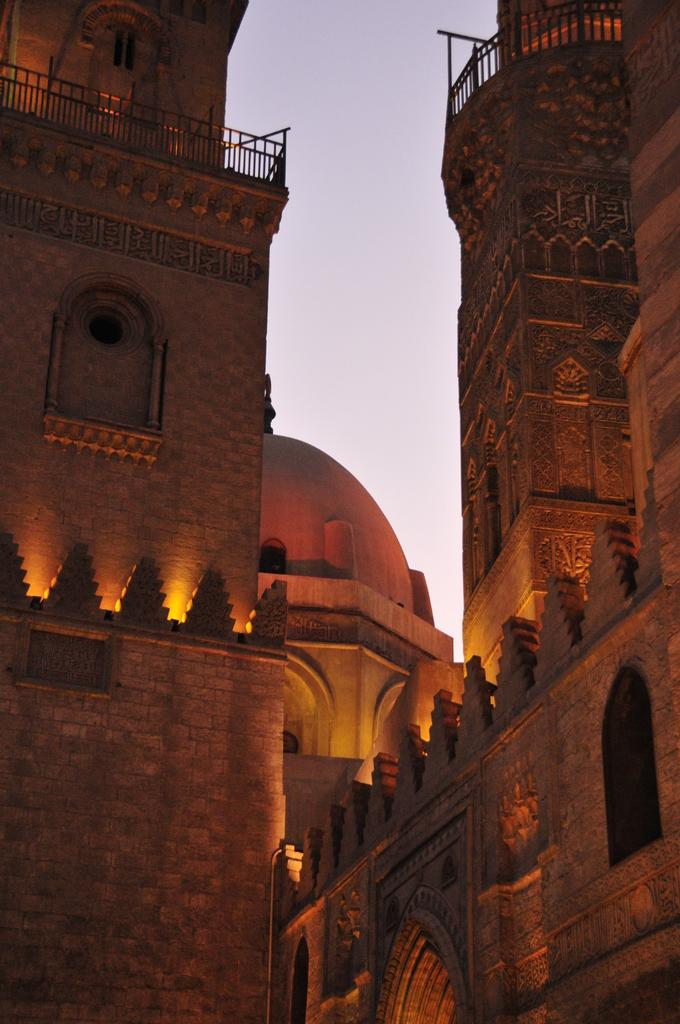What type of structures are present in the image? There are buildings in the image. What feature can be seen on the buildings? There are windows visible in the image. What can be seen illuminating the buildings? There are lights in the image. What type of barrier is present in the image? There is a fence in the image. What part of the natural environment is visible in the image? The sky is visible in the image. What is the tendency of the stomach to growl in the image? There is no stomach present in the image, so it is not possible to determine any tendencies related to it. 